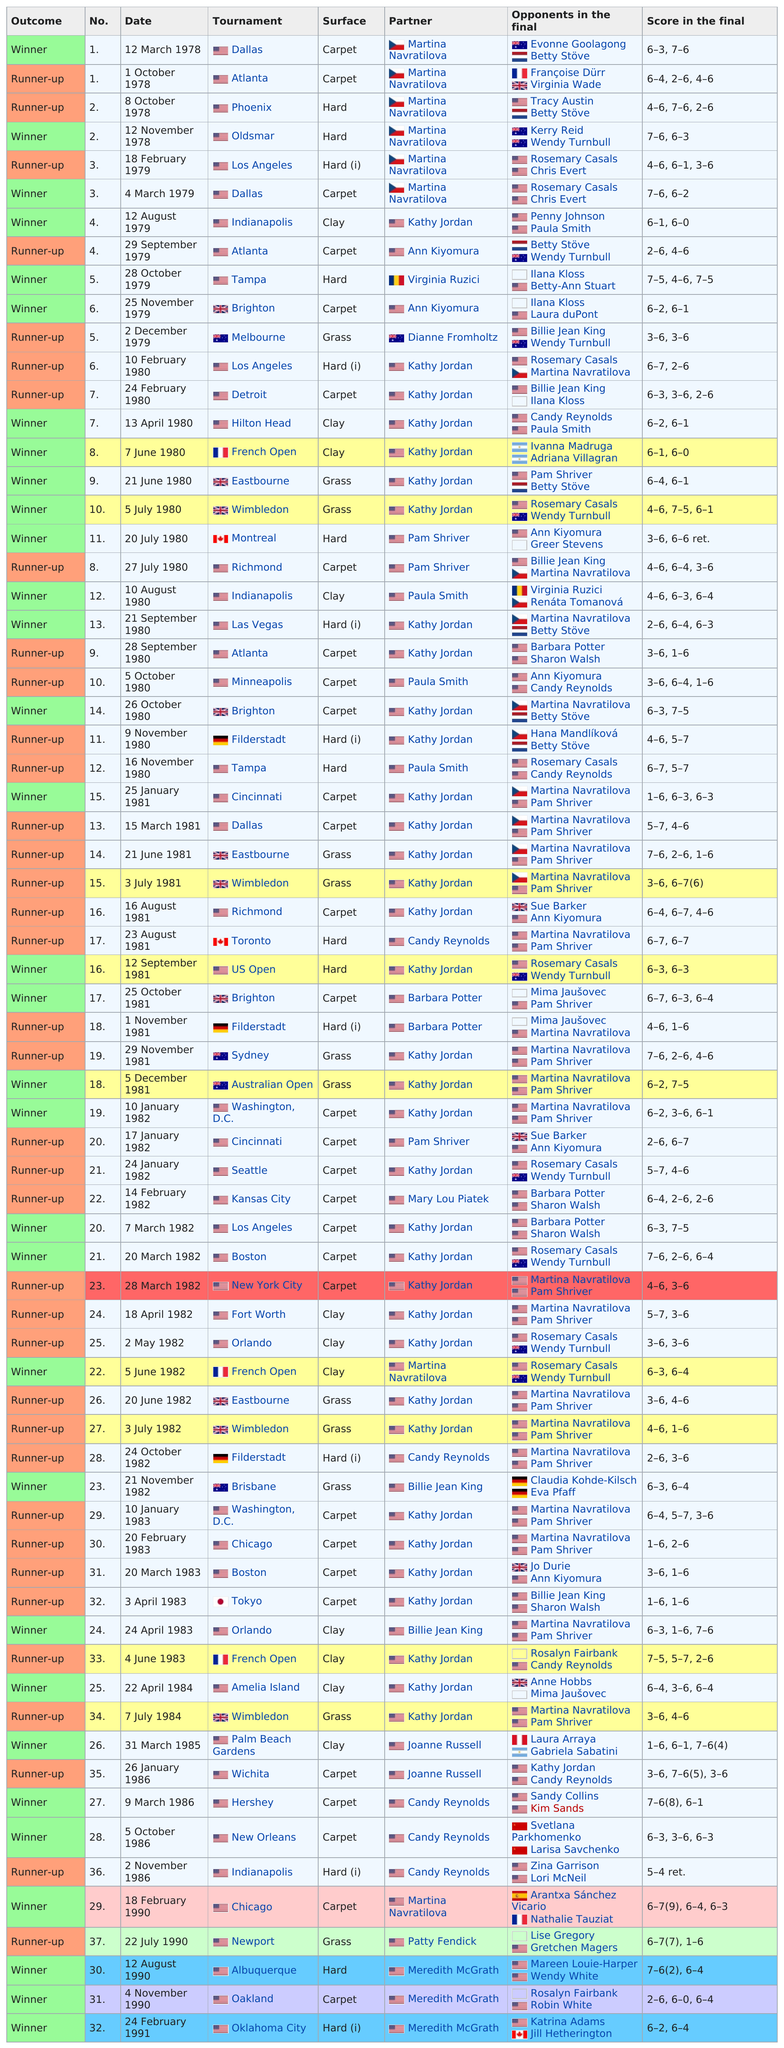Indicate a few pertinent items in this graphic. In 1991, the only tournament was held in Oklahoma City. The match played on November 12, 1978, which took place on a hard surface, was preceded by another match that was also played on a hard surface, as the previous match was also played on a hard surface. The location with more tournaments is Los Angeles, as declared by the sentence itself. The outcome of the October 8 game in Phoenix was that the runner-up was declared the winner. Ann Smith competed in 11 doubles finals before the year 1980. 